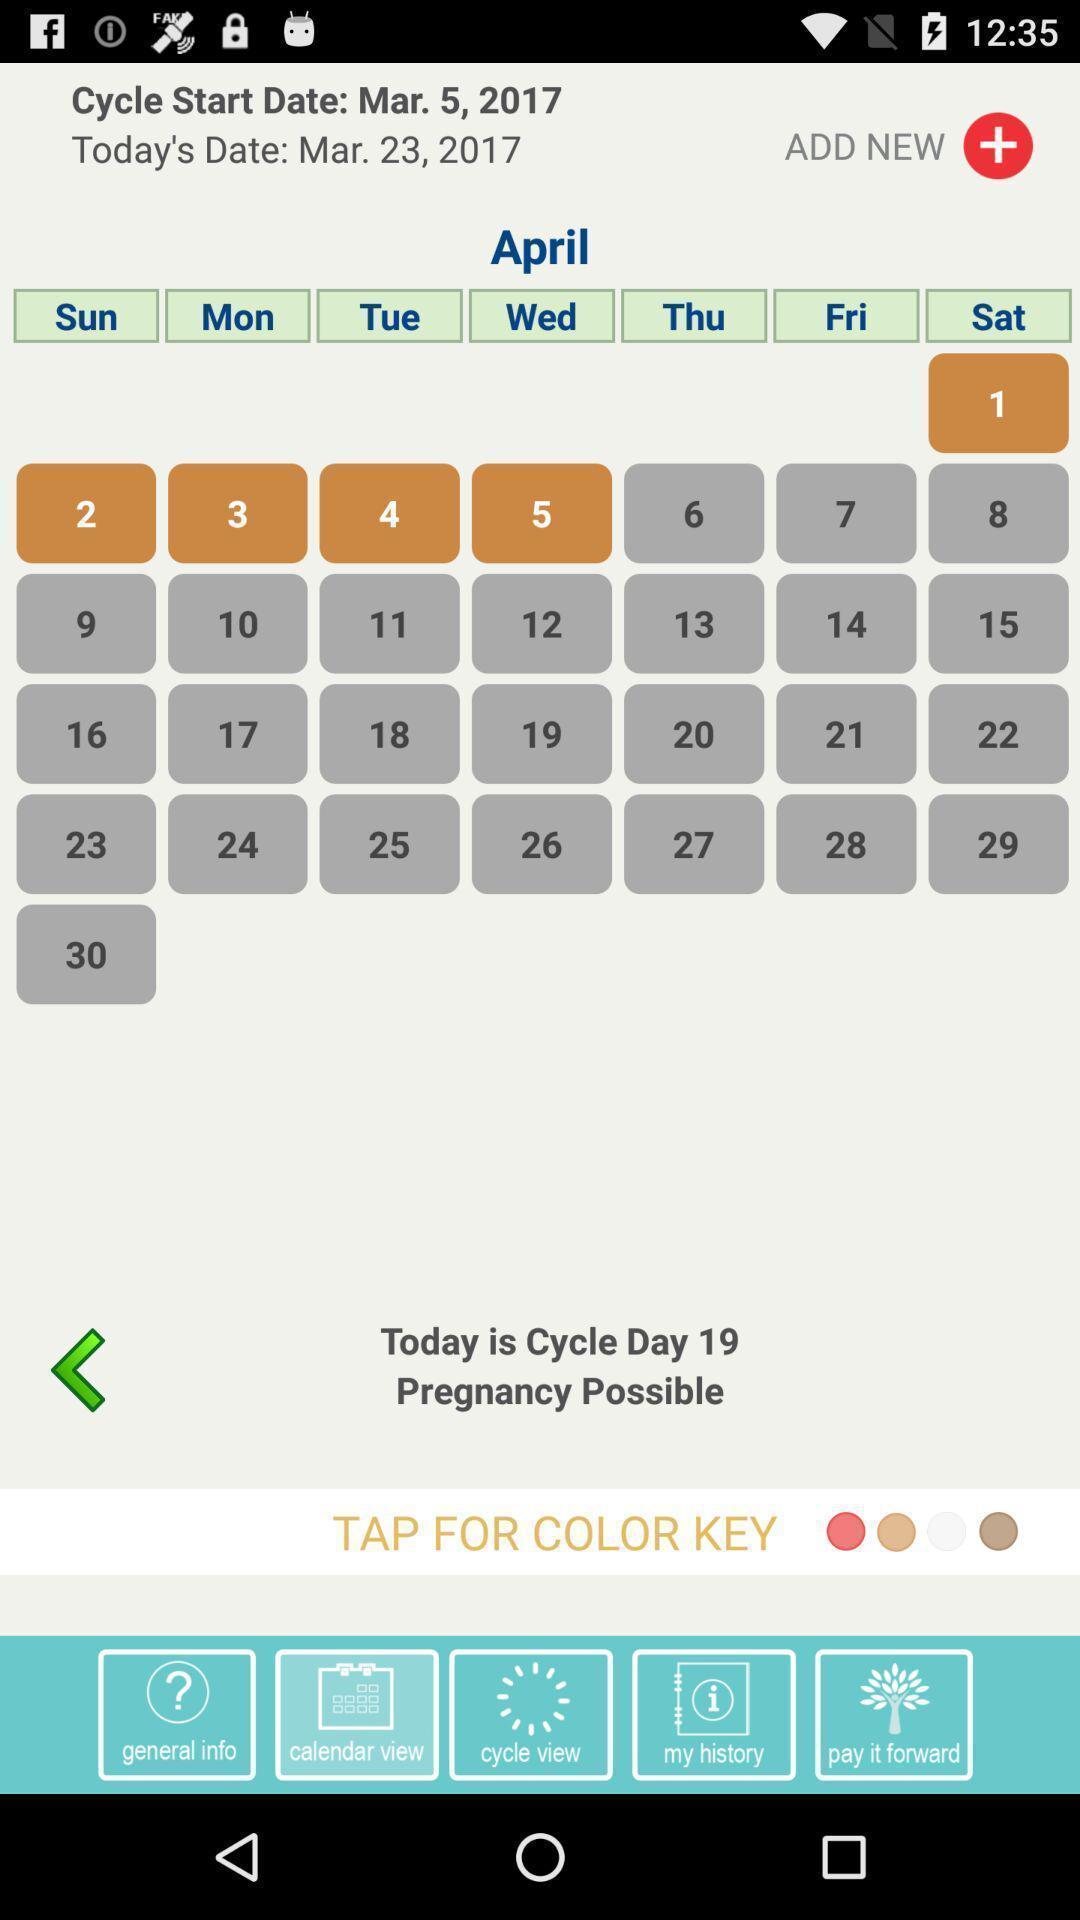Summarize the information in this screenshot. Page displays dates and weeks in app. 